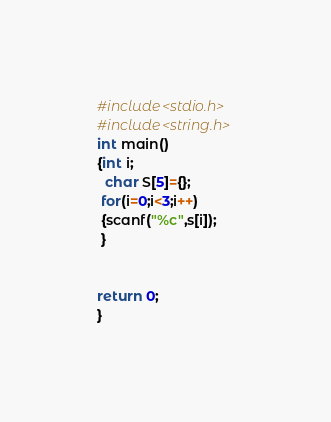Convert code to text. <code><loc_0><loc_0><loc_500><loc_500><_C_>#include<stdio.h>
#include<string.h>
int main()
{int i;
  char S[5]={};
 for(i=0;i<3;i++)
 {scanf("%c",s[i]);
 }
 

return 0;
}</code> 